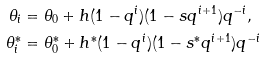<formula> <loc_0><loc_0><loc_500><loc_500>\theta _ { i } & = \theta _ { 0 } + h ( 1 - q ^ { i } ) ( 1 - s q ^ { i + 1 } ) q ^ { - i } , \\ \theta _ { i } ^ { * } & = \theta _ { 0 } ^ { * } + h ^ { * } ( 1 - q ^ { i } ) ( 1 - s ^ { * } q ^ { i + 1 } ) q ^ { - i }</formula> 